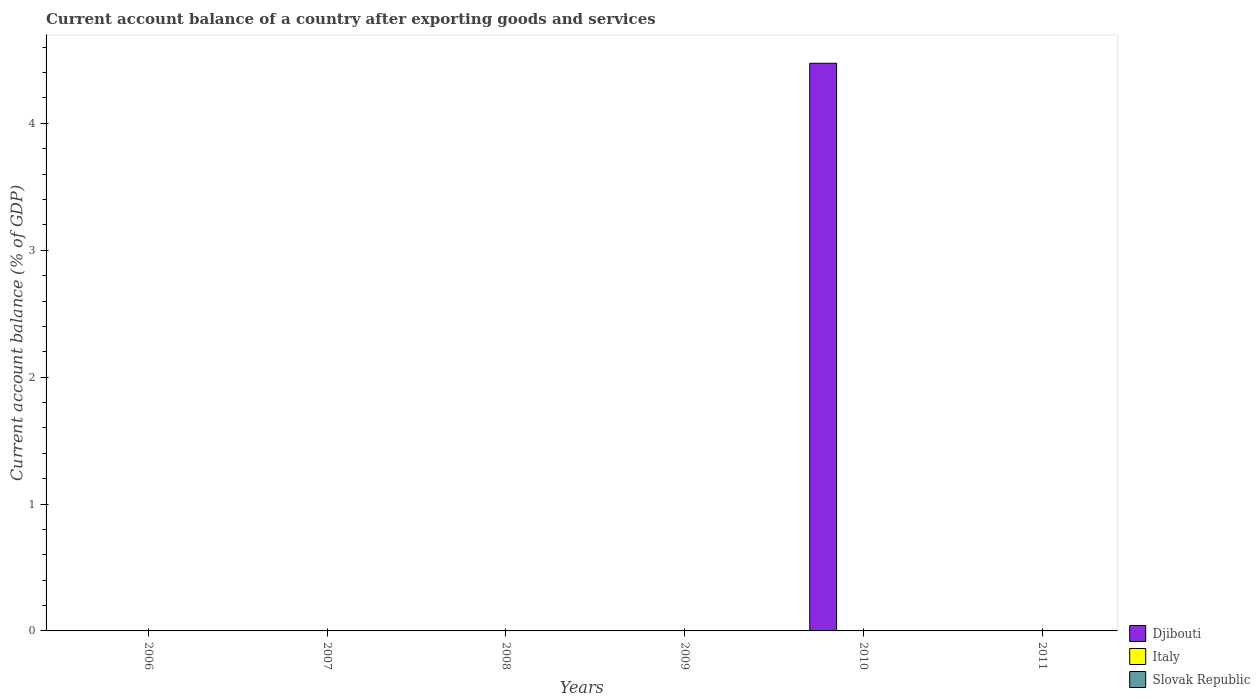Are the number of bars per tick equal to the number of legend labels?
Your response must be concise. No. How many bars are there on the 6th tick from the right?
Keep it short and to the point. 0. In how many cases, is the number of bars for a given year not equal to the number of legend labels?
Offer a terse response. 6. What is the account balance in Djibouti in 2010?
Make the answer very short. 4.47. Across all years, what is the maximum account balance in Djibouti?
Your response must be concise. 4.47. Across all years, what is the minimum account balance in Slovak Republic?
Give a very brief answer. 0. What is the total account balance in Djibouti in the graph?
Keep it short and to the point. 4.47. What is the average account balance in Djibouti per year?
Your answer should be very brief. 0.75. What is the difference between the highest and the lowest account balance in Djibouti?
Provide a succinct answer. 4.47. In how many years, is the account balance in Slovak Republic greater than the average account balance in Slovak Republic taken over all years?
Your answer should be compact. 0. Is it the case that in every year, the sum of the account balance in Slovak Republic and account balance in Djibouti is greater than the account balance in Italy?
Keep it short and to the point. No. Are all the bars in the graph horizontal?
Offer a terse response. No. Does the graph contain any zero values?
Offer a very short reply. Yes. How are the legend labels stacked?
Keep it short and to the point. Vertical. What is the title of the graph?
Ensure brevity in your answer.  Current account balance of a country after exporting goods and services. What is the label or title of the X-axis?
Provide a succinct answer. Years. What is the label or title of the Y-axis?
Ensure brevity in your answer.  Current account balance (% of GDP). What is the Current account balance (% of GDP) in Djibouti in 2006?
Your response must be concise. 0. What is the Current account balance (% of GDP) of Slovak Republic in 2006?
Offer a very short reply. 0. What is the Current account balance (% of GDP) of Djibouti in 2008?
Give a very brief answer. 0. What is the Current account balance (% of GDP) of Slovak Republic in 2008?
Your answer should be compact. 0. What is the Current account balance (% of GDP) in Djibouti in 2009?
Ensure brevity in your answer.  0. What is the Current account balance (% of GDP) of Italy in 2009?
Keep it short and to the point. 0. What is the Current account balance (% of GDP) in Slovak Republic in 2009?
Your answer should be compact. 0. What is the Current account balance (% of GDP) of Djibouti in 2010?
Your answer should be compact. 4.47. What is the Current account balance (% of GDP) of Italy in 2010?
Provide a succinct answer. 0. What is the Current account balance (% of GDP) of Slovak Republic in 2011?
Ensure brevity in your answer.  0. Across all years, what is the maximum Current account balance (% of GDP) of Djibouti?
Give a very brief answer. 4.47. Across all years, what is the minimum Current account balance (% of GDP) of Djibouti?
Ensure brevity in your answer.  0. What is the total Current account balance (% of GDP) in Djibouti in the graph?
Ensure brevity in your answer.  4.47. What is the total Current account balance (% of GDP) of Italy in the graph?
Your answer should be compact. 0. What is the total Current account balance (% of GDP) of Slovak Republic in the graph?
Give a very brief answer. 0. What is the average Current account balance (% of GDP) in Djibouti per year?
Offer a very short reply. 0.75. What is the average Current account balance (% of GDP) in Slovak Republic per year?
Your answer should be very brief. 0. What is the difference between the highest and the lowest Current account balance (% of GDP) in Djibouti?
Offer a terse response. 4.47. 